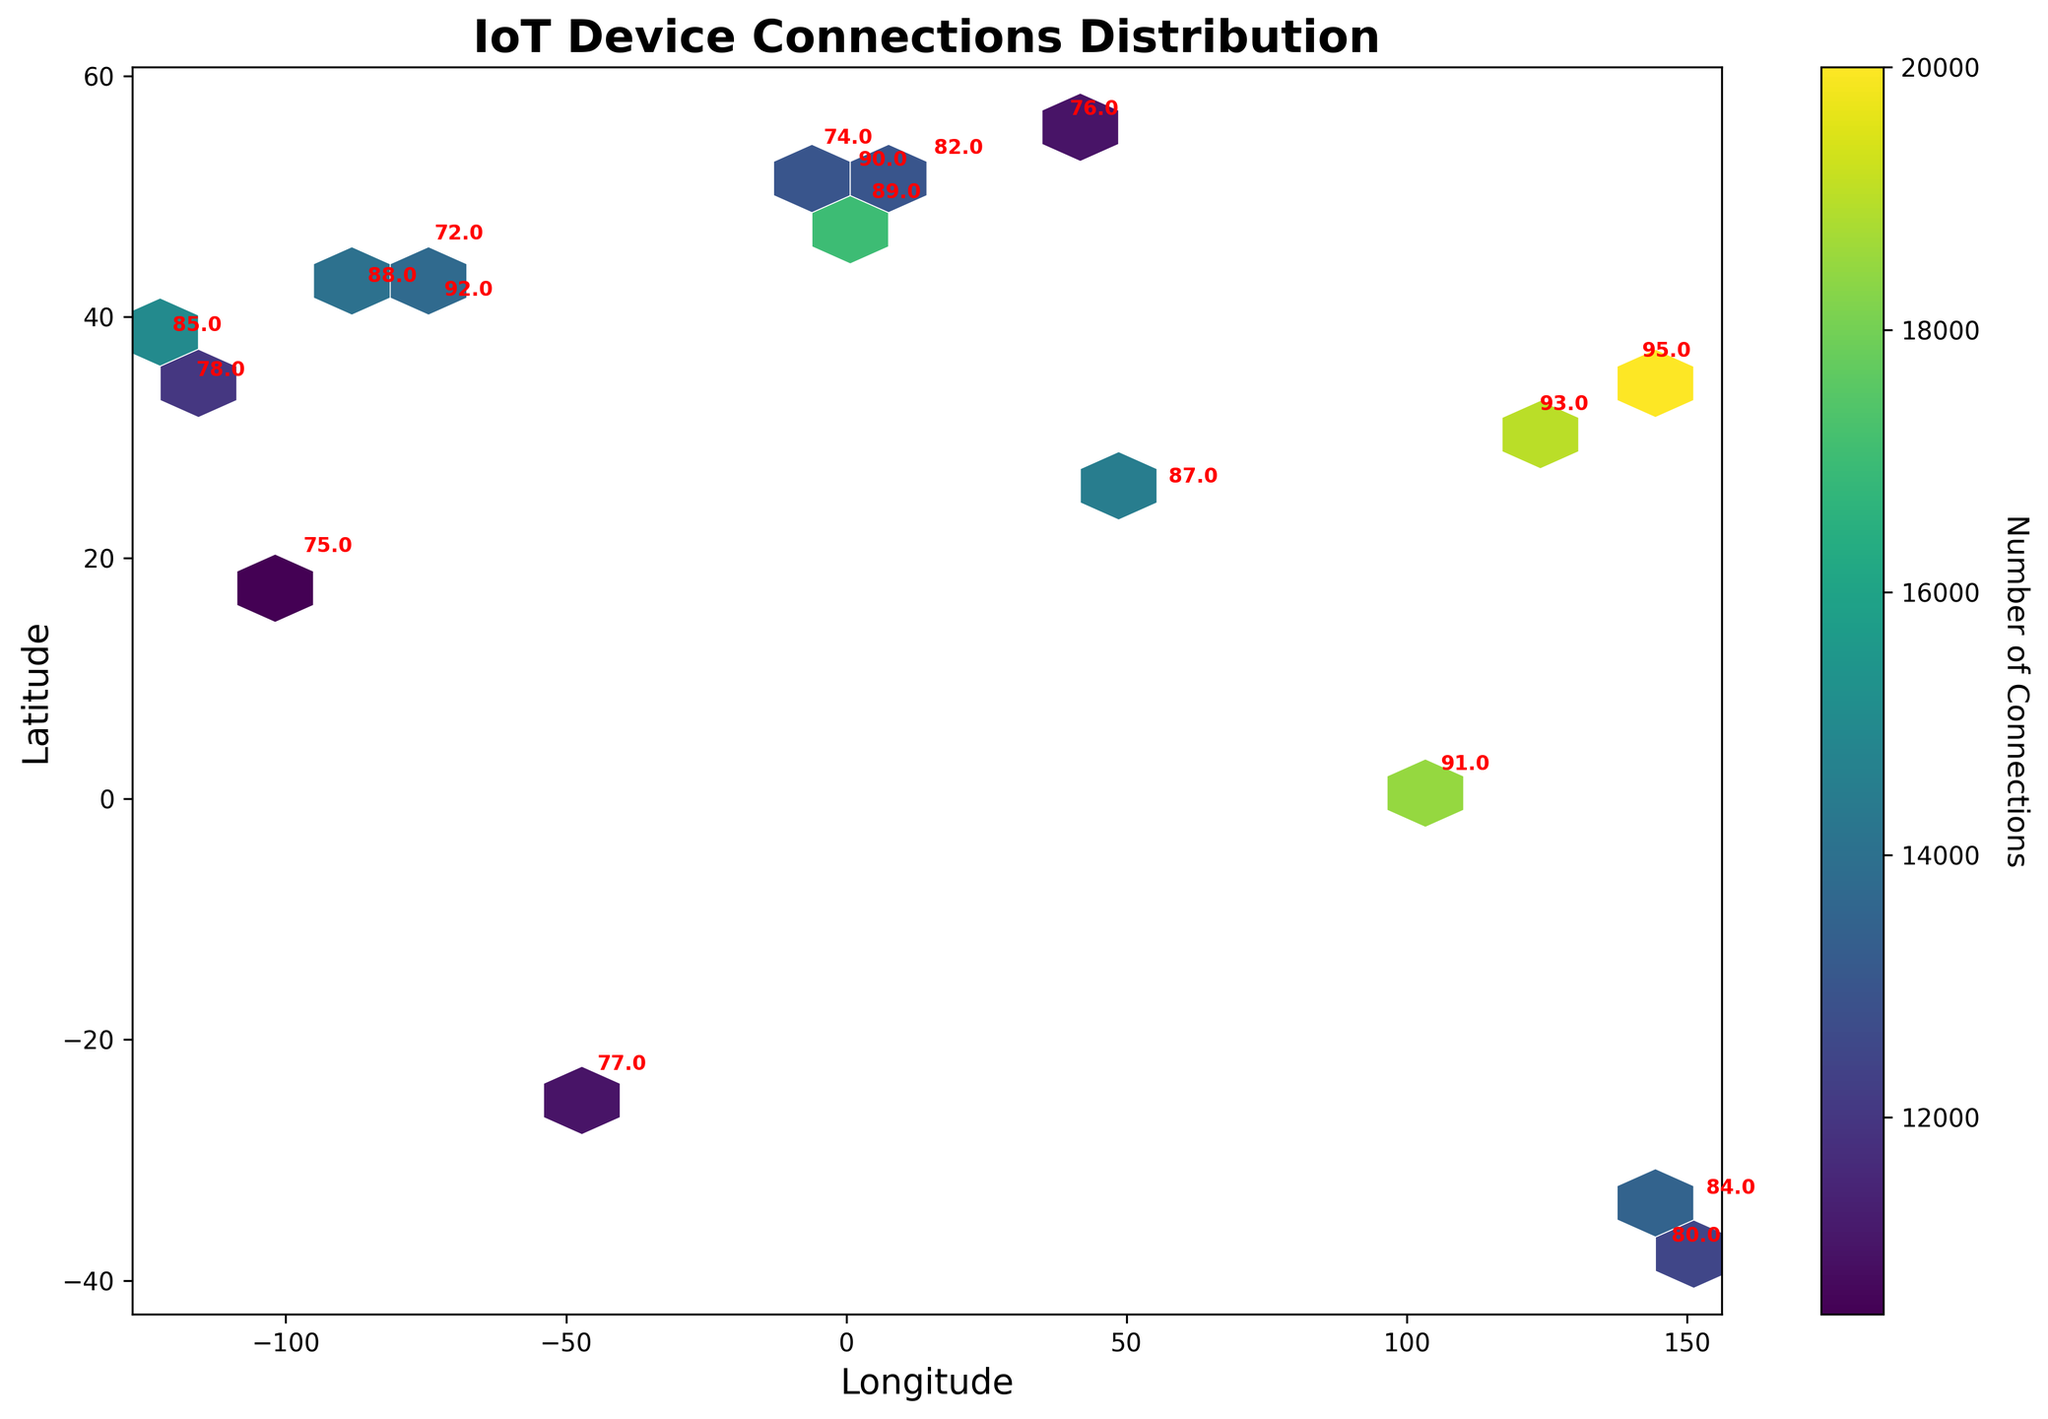What is the title of the plot? The title of the plot is typically found at the top and describes what the visualization is about. In this case, it specifies the distribution of IoT device connections.
Answer: IoT Device Connections Distribution What are the ranges of the Latitude and Longitude axes? The Latitude and Longitude ranges can be determined by looking at the minimum and maximum values marked along the axes. These ranges help set the geographic boundaries of the plot.
Answer: Latitude: ~-38 to ~56, Longitude: ~-128 to ~144 Which area has the maximum number of IoT device connections? To find the area with the maximum connections, locate the hexagons with the most intense color, as the color bar indicates the number of connections.
Answer: Tokyo, Japan What is the Signal Strength value at coordinates (37.7749, -122.4194)? Signal strength values are annotated near each data point. Look up the value at the specified coordinates.
Answer: 85 Which region has the highest signal strength annotation? The highest signal strength can be found by examining the numeric annotations on the plot and identifying the maximum value.
Answer: Tokyo, Japan (95) Compare the number of IoT device connections between Singapore and Dubai. To compare, refer to the color intensity of the hexagons around both locations and check the color bar that indicates the number of connections. Singapore appears more intense than Dubai.
Answer: Singapore has more connections How is the color used in the hexbin plot? The hexbin plot uses a color scale, represented by a color bar, to indicate the density of IoT device connections. Darker shades denote a higher number of connections, and lighter shades denote fewer connections.
Answer: Indicates connection density What's the average Signal Strength value of the data points? List all the signal strength values, add them up, and divide by the number of data points to calculate the average. Signal_Strengths = [85, 92, 78, 88, 90, 89, 95, 93, 82, 76, 91, 87, 84, 80, 75, 77, 72, 74]. The sum is 1518, and there are 18 data points, so 1518/18 = 84.33
Answer: 84.33 Which city has a Latitude close to the middle value of the dataset? Sort the Latitude values and find the middle value. The data has 18 points; the middle ones are the 9th and 10th. Latitudes (sorted): [ -37.8136, -33.8688, 1.3521, 19.4326, 25.2048, 31.2304, 34.0522, 35.6762, 37.7749, 40.7128, 41.8781, 45.4215, 48.8566, 51.5074, 52.5200, 53.3498, 55.7558]. The median is between 36.72555 and 37.7749, close to San Francisco.
Answer: San Francisco, USA 